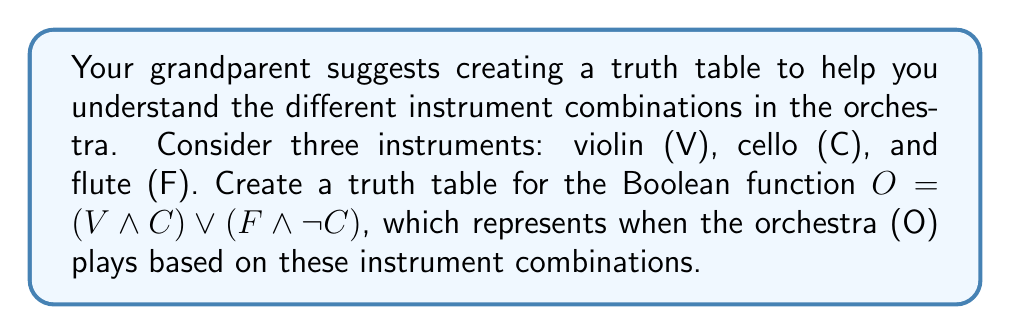Can you solve this math problem? Let's approach this step-by-step:

1) First, identify the variables: V (violin), C (cello), and F (flute).

2) Create a truth table with 8 rows (2^3 = 8 combinations):

   V | C | F | (V ∧ C) | (F ∧ ¬C) | O = (V ∧ C) ∨ (F ∧ ¬C)
   --|---|---|---------|----------|-------------------------
   0 | 0 | 0 |    0    |    0     |           0
   0 | 0 | 1 |    0    |    1     |           1
   0 | 1 | 0 |    0    |    0     |           0
   0 | 1 | 1 |    0    |    0     |           0
   1 | 0 | 0 |    0    |    0     |           0
   1 | 0 | 1 |    0    |    1     |           1
   1 | 1 | 0 |    1    |    0     |           1
   1 | 1 | 1 |    1    |    0     |           1

3) Evaluate $(V \wedge C)$:
   - This is 1 only when both V and C are 1 (rows 7 and 8).

4) Evaluate $(F \wedge \neg C)$:
   - This is 1 when F is 1 and C is 0 (rows 2 and 6).

5) Finally, evaluate $O = (V \wedge C) \vee (F \wedge \neg C)$:
   - This is 1 when either $(V \wedge C)$ or $(F \wedge \neg C)$ is 1.

The orchestra plays (O = 1) when:
- The violin and cello play together (V = 1, C = 1), regardless of the flute.
- The flute plays without the cello (F = 1, C = 0), regardless of the violin.
Answer: $$
\begin{array}{ccc|c}
V & C & F & O \\
\hline
0 & 0 & 0 & 0 \\
0 & 0 & 1 & 1 \\
0 & 1 & 0 & 0 \\
0 & 1 & 1 & 0 \\
1 & 0 & 0 & 0 \\
1 & 0 & 1 & 1 \\
1 & 1 & 0 & 1 \\
1 & 1 & 1 & 1 \\
\end{array}
$$ 